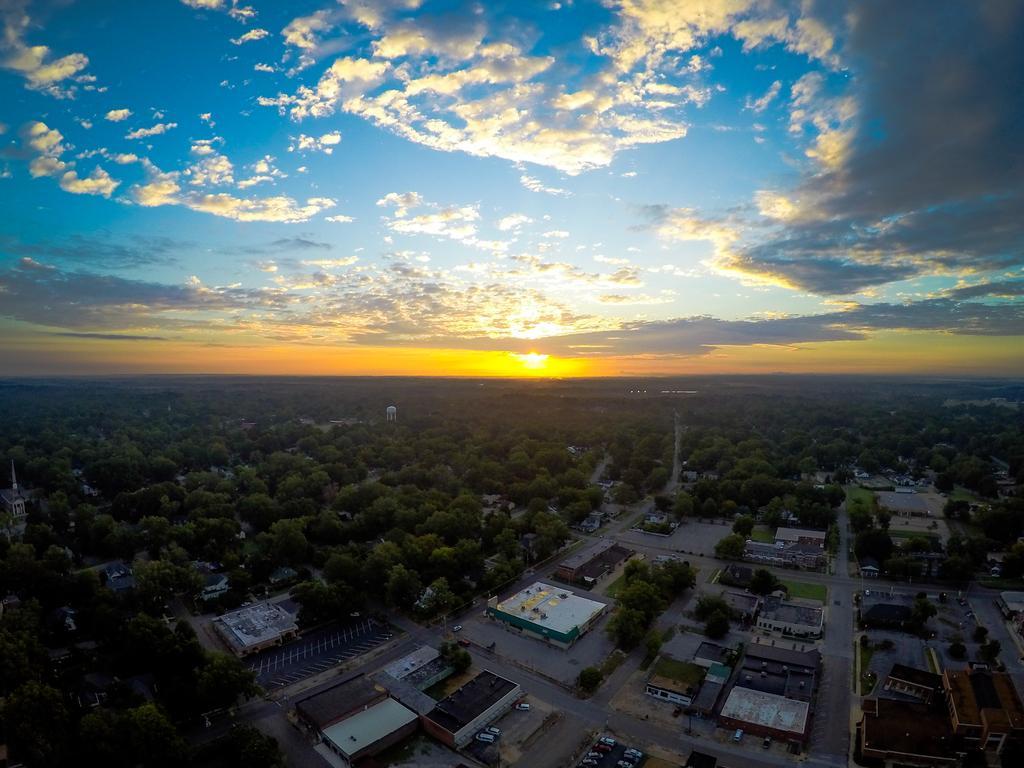How would you summarize this image in a sentence or two? In this picture we can see some buildings and vehicles at the bottom, in the background there are some trees, we can see the sky and clouds at the top of the picture. 